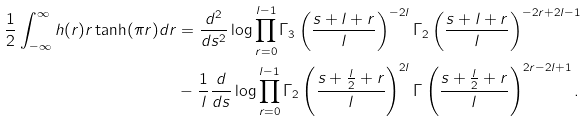<formula> <loc_0><loc_0><loc_500><loc_500>\frac { 1 } { 2 } \int _ { - \infty } ^ { \infty } h ( r ) r \tanh ( \pi r ) d r & = \frac { d ^ { 2 } } { d s ^ { 2 } } \log \prod _ { r = 0 } ^ { l - 1 } \Gamma _ { 3 } \left ( \frac { s + l + r } { l } \right ) ^ { - 2 l } \Gamma _ { 2 } \left ( \frac { s + l + r } { l } \right ) ^ { - 2 r + 2 l - 1 } \\ & - \frac { 1 } { l } \frac { d } { d s } \log \prod _ { r = 0 } ^ { l - 1 } \Gamma _ { 2 } \left ( \frac { s + \frac { l } { 2 } + r } { l } \right ) ^ { 2 l } \Gamma \left ( \frac { s + \frac { l } { 2 } + r } { l } \right ) ^ { 2 r - 2 l + 1 } .</formula> 